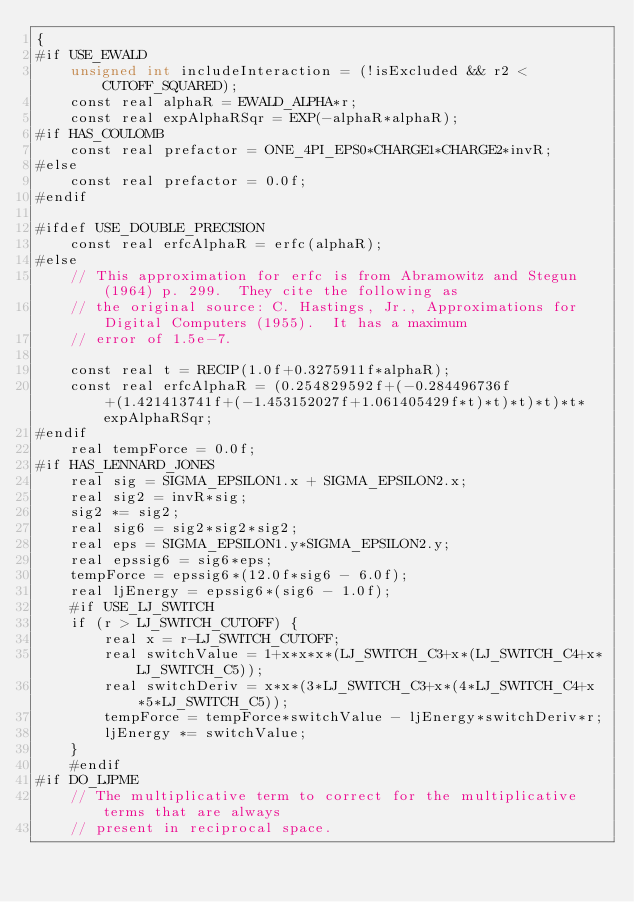<code> <loc_0><loc_0><loc_500><loc_500><_Cuda_>{
#if USE_EWALD
    unsigned int includeInteraction = (!isExcluded && r2 < CUTOFF_SQUARED);
    const real alphaR = EWALD_ALPHA*r;
    const real expAlphaRSqr = EXP(-alphaR*alphaR);
#if HAS_COULOMB
    const real prefactor = ONE_4PI_EPS0*CHARGE1*CHARGE2*invR;
#else
    const real prefactor = 0.0f;
#endif

#ifdef USE_DOUBLE_PRECISION
    const real erfcAlphaR = erfc(alphaR);
#else
    // This approximation for erfc is from Abramowitz and Stegun (1964) p. 299.  They cite the following as
    // the original source: C. Hastings, Jr., Approximations for Digital Computers (1955).  It has a maximum
    // error of 1.5e-7.

    const real t = RECIP(1.0f+0.3275911f*alphaR);
    const real erfcAlphaR = (0.254829592f+(-0.284496736f+(1.421413741f+(-1.453152027f+1.061405429f*t)*t)*t)*t)*t*expAlphaRSqr;
#endif
    real tempForce = 0.0f;
#if HAS_LENNARD_JONES
    real sig = SIGMA_EPSILON1.x + SIGMA_EPSILON2.x;
    real sig2 = invR*sig;
    sig2 *= sig2;
    real sig6 = sig2*sig2*sig2;
    real eps = SIGMA_EPSILON1.y*SIGMA_EPSILON2.y;
    real epssig6 = sig6*eps;
    tempForce = epssig6*(12.0f*sig6 - 6.0f);
    real ljEnergy = epssig6*(sig6 - 1.0f);
    #if USE_LJ_SWITCH
    if (r > LJ_SWITCH_CUTOFF) {
        real x = r-LJ_SWITCH_CUTOFF;
        real switchValue = 1+x*x*x*(LJ_SWITCH_C3+x*(LJ_SWITCH_C4+x*LJ_SWITCH_C5));
        real switchDeriv = x*x*(3*LJ_SWITCH_C3+x*(4*LJ_SWITCH_C4+x*5*LJ_SWITCH_C5));
        tempForce = tempForce*switchValue - ljEnergy*switchDeriv*r;
        ljEnergy *= switchValue;
    }
    #endif
#if DO_LJPME
    // The multiplicative term to correct for the multiplicative terms that are always
    // present in reciprocal space.</code> 